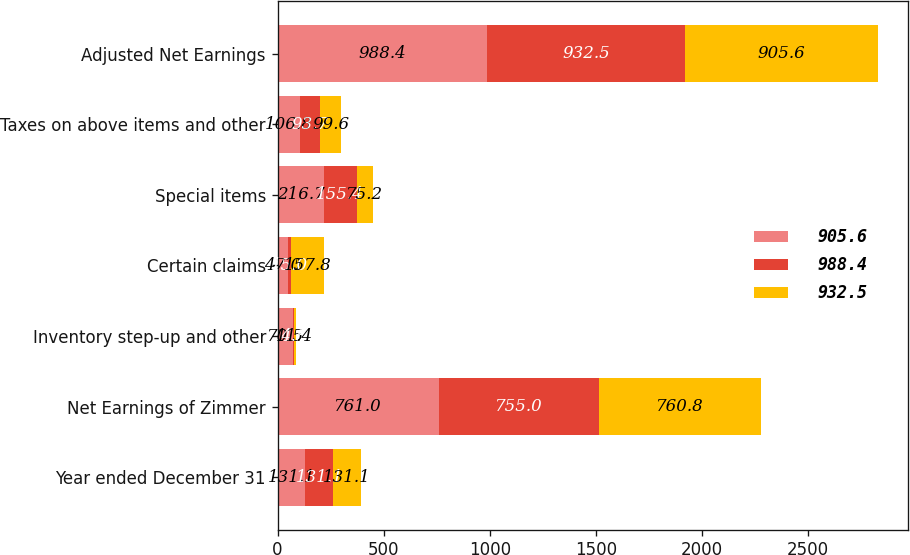Convert chart. <chart><loc_0><loc_0><loc_500><loc_500><stacked_bar_chart><ecel><fcel>Year ended December 31<fcel>Net Earnings of Zimmer<fcel>Inventory step-up and other<fcel>Certain claims<fcel>Special items<fcel>Taxes on above items and other<fcel>Adjusted Net Earnings<nl><fcel>905.6<fcel>131.1<fcel>761<fcel>70.5<fcel>47<fcel>216.7<fcel>106.8<fcel>988.4<nl><fcel>988.4<fcel>131.1<fcel>755<fcel>4.8<fcel>15<fcel>155.4<fcel>93.7<fcel>932.5<nl><fcel>932.5<fcel>131.1<fcel>760.8<fcel>11.4<fcel>157.8<fcel>75.2<fcel>99.6<fcel>905.6<nl></chart> 